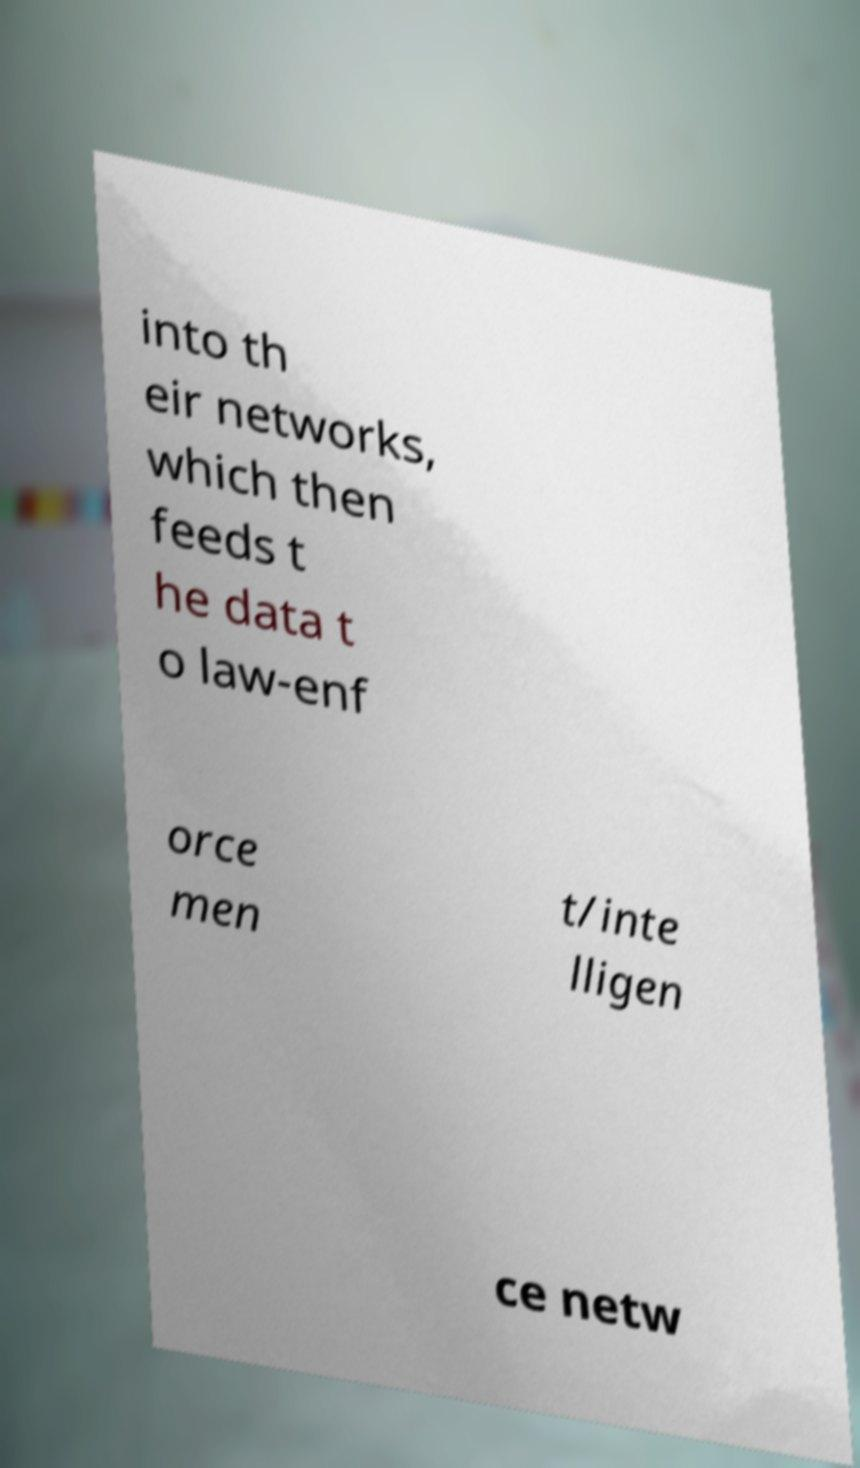What messages or text are displayed in this image? I need them in a readable, typed format. into th eir networks, which then feeds t he data t o law-enf orce men t/inte lligen ce netw 